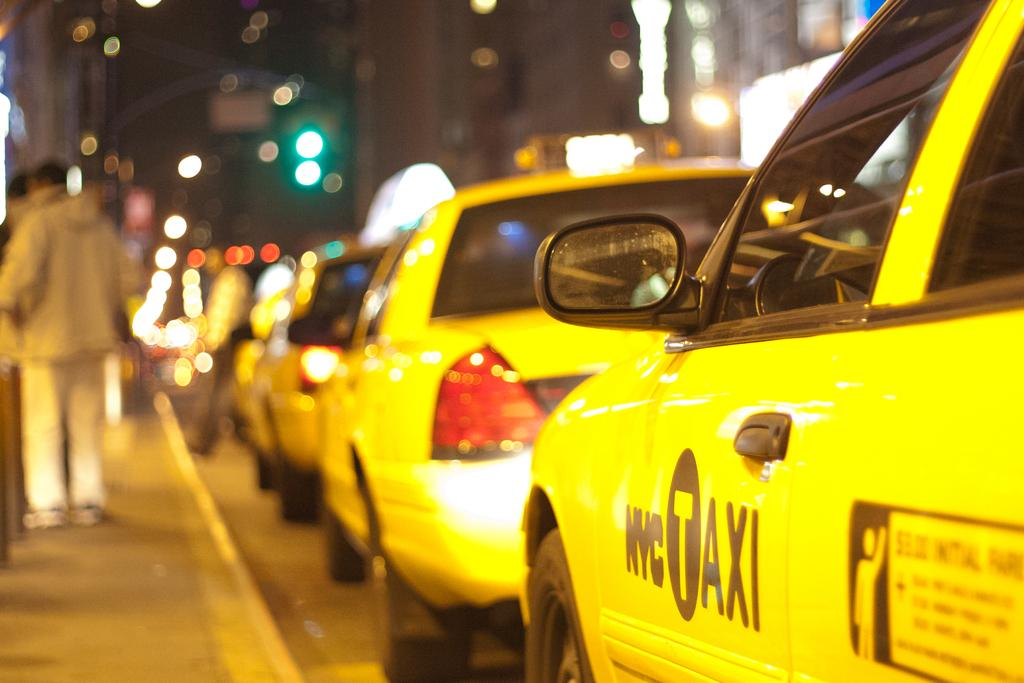<image>
Give a short and clear explanation of the subsequent image. A row of yellow NYC Taxis lined up at the curb. 